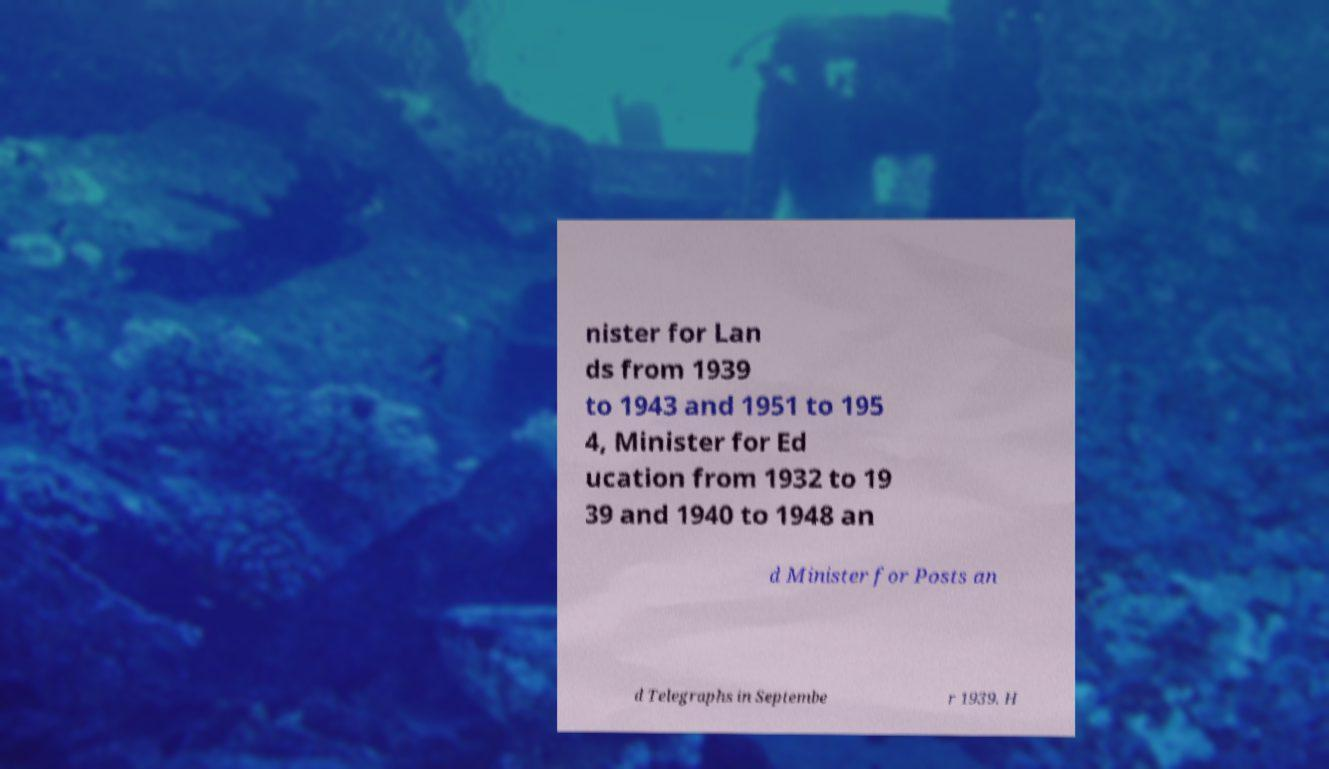Could you extract and type out the text from this image? nister for Lan ds from 1939 to 1943 and 1951 to 195 4, Minister for Ed ucation from 1932 to 19 39 and 1940 to 1948 an d Minister for Posts an d Telegraphs in Septembe r 1939. H 